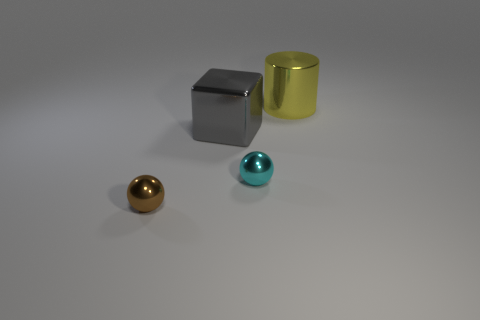Do the metallic thing behind the gray metallic thing and the big metal block have the same color?
Offer a terse response. No. Is there anything else that has the same material as the big cylinder?
Ensure brevity in your answer.  Yes. What number of small cyan shiny objects are the same shape as the tiny brown metallic object?
Your response must be concise. 1. There is a cyan ball that is the same material as the cylinder; what size is it?
Your answer should be very brief. Small. There is a metallic ball on the left side of the ball on the right side of the big block; is there a yellow metal cylinder that is on the left side of it?
Offer a terse response. No. Do the metal thing to the right of the cyan shiny thing and the gray shiny thing have the same size?
Give a very brief answer. Yes. How many yellow cylinders have the same size as the brown ball?
Keep it short and to the point. 0. Do the shiny block and the metallic cylinder have the same color?
Keep it short and to the point. No. What shape is the yellow metal thing?
Provide a succinct answer. Cylinder. Are there any shiny objects that have the same color as the large cube?
Your answer should be compact. No. 